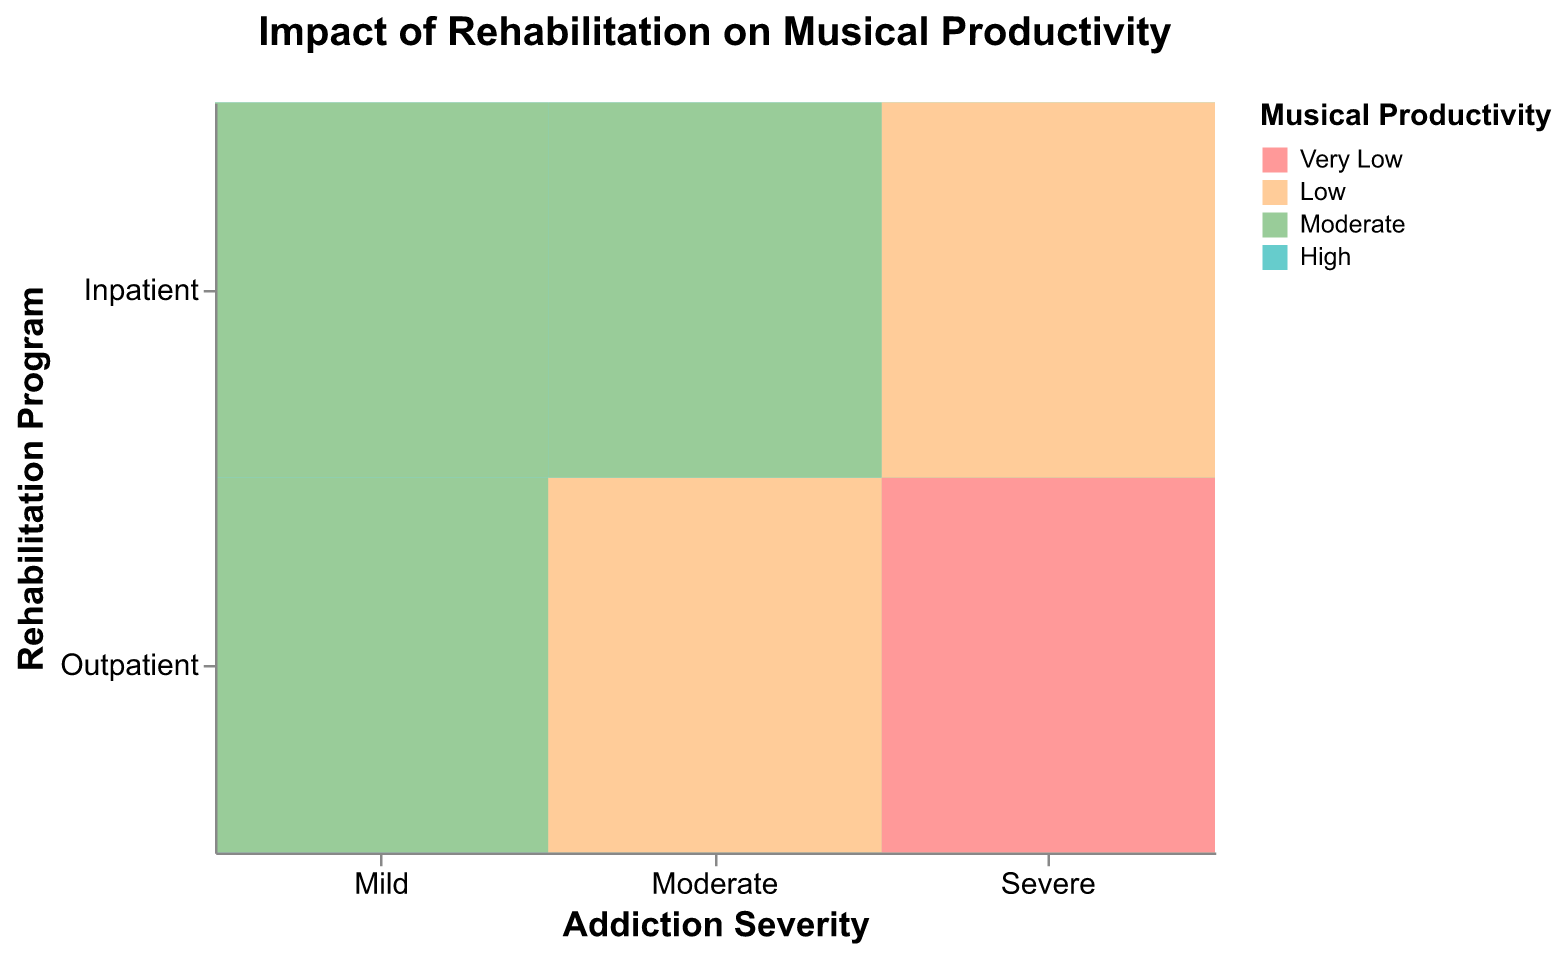What is the title of the figure? The title is typically located at the top of the figure, and it describes the subject of the plot. Here, the title explicitly states what is being analyzed.
Answer: Impact of Rehabilitation on Musical Productivity Which addiction severity level has the highest musical productivity with the Inpatient rehabilitation program? By looking at the cells colored with the "High" category within the Inpatient rehabilitation program row, we identify that "Mild" severity has this highest productivity.
Answer: Mild How does musical productivity differ between Inpatient and Outpatient rehabilitation programs for Severe addiction severity? To answer this, compare the color-coded productivity levels for the Severe row across both rehabilitation programs. Severe Outpatient has "Low" and "Very Low" while Severe Inpatient has "Moderate" and "Low".
Answer: Outpatient has lower productivity than Inpatient What are the musical productivity levels associated with Moderate addiction severity in the Outpatient program? Examine the cells that correspond to Moderate severity and the Outpatient program. The colors represent the productivity levels listed in the legend.
Answer: Moderate and Low Which rehabilitation program typically leads to higher musical productivity for Moderate addiction severity? Compare the productivity levels (color-coded) for Moderate severity between Inpatient and Outpatient rehabilitation programs. Inpatient has "Moderate" and "High", while Outpatient has "Moderate" and "Low".
Answer: Inpatient Among all addiction severity levels, which rehabilitation program shows the most varied range of musical productivity? Look for the rehabilitation program with the widest range of colors from different productivity categories across all severity levels. Both programs show multiple productivity levels, but Inpatient shows a higher range of "High", "Moderate", and "Low".
Answer: Inpatient For Mild addiction severity, how many different musical productivity levels are present in the Inpatient program? Count the distinct productivity levels (colors) for the Mild severity within the Inpatient rehabilitation program row.
Answer: Two (High and Moderate) What is the musical productivity for Severe addiction severity in the Outpatient program? Identify the colors and corresponding productivity levels for cells under Severe addiction severity and Outpatient program.
Answer: Low and Very Low Based on the plot, which rehabilitation program would you recommend for maximum musical productivity among individuals with Mild addiction severity? Consider the productivity levels (colors) under Mild addiction severity for both rehabilitation programs. Identify the program with the highest productivity.
Answer: Either program (both have "High" productivity) Do any addiction severity levels have the same musical productivity levels across different rehabilitation programs? Look for rows where the productivity levels (colors) under different rehabilitation programs are identical. Mild Inpatient and Outpatient both show "High" and "Moderate" levels.
Answer: Yes, Mild 